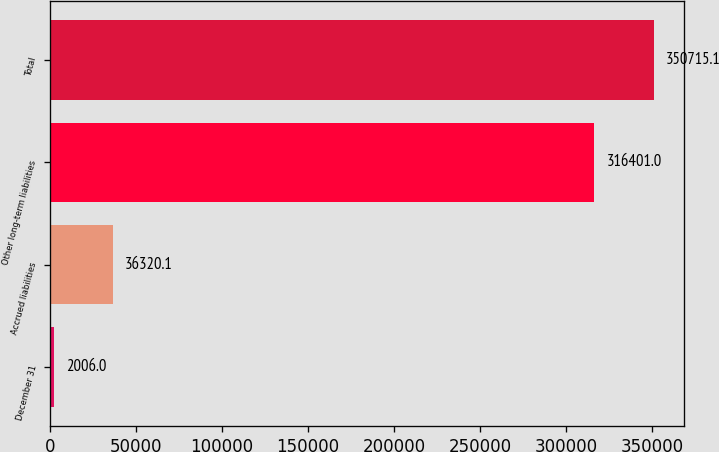Convert chart. <chart><loc_0><loc_0><loc_500><loc_500><bar_chart><fcel>December 31<fcel>Accrued liabilities<fcel>Other long-term liabilities<fcel>Total<nl><fcel>2006<fcel>36320.1<fcel>316401<fcel>350715<nl></chart> 